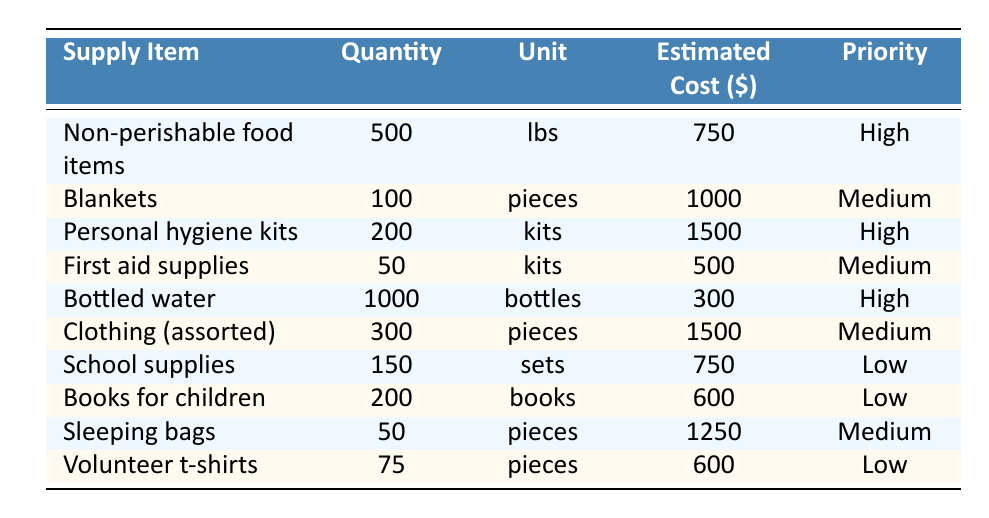What is the total estimated cost of the high-priority supplies? To find the total estimated cost of high-priority supplies, we look at the rows where the Priority column is marked "High". The supplies are: Non-perishable food items ($750), Personal hygiene kits ($1500), and Bottled water ($300). Summing these amounts gives us: 750 + 1500 + 300 = 2550.
Answer: 2550 How many blankets are needed for the outreach programs? The table shows that 100 blankets are needed as indicated in the Quantity column.
Answer: 100 Is bottled water considered a low-priority supply? In the table, bottled water is classified as a high-priority supply, which means the statement is false.
Answer: No What is the average quantity of supplies for medium-priority items? The medium-priority items and their quantities are: Blankets (100), First aid supplies (50), Clothing (300), Sleeping bags (50). To find the average, we sum these quantities: 100 + 50 + 300 + 50 = 500. There are 4 items, so the average is 500 / 4 = 125.
Answer: 125 Which supply item has the lowest estimated cost? By examining the Estimated Cost column, we see that bottled water is the least expensive at $300. All other supplies cost more than this value.
Answer: Bottled water How many more personal hygiene kits are required compared to first aid supplies? From the table, we see that 200 personal hygiene kits are needed while first aid supplies list only 50 kits. To find how many more are needed, we subtract: 200 - 50 = 150.
Answer: 150 Are there more clothing pieces needed than sleeping bags? The table indicates that 300 pieces of clothing are required and only 50 sleeping bags. Therefore, there are indeed more clothing pieces needed.
Answer: Yes What is the total quantity of supplies listed in the table? To find the total quantity, we sum the quantities of all items listed in the Quantity column: 500 (food) + 100 (blankets) + 200 (hygiene kits) + 50 (first aid) + 1000 (bottled water) + 300 (clothing) + 150 (school supplies) + 200 (books) + 50 (sleeping bags) + 75 (t-shirts) = 2625.
Answer: 2625 